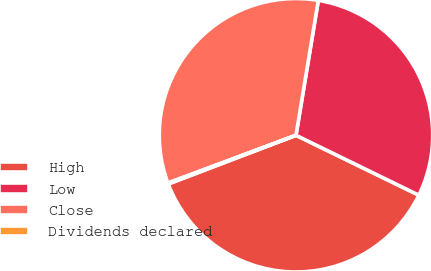<chart> <loc_0><loc_0><loc_500><loc_500><pie_chart><fcel>High<fcel>Low<fcel>Close<fcel>Dividends declared<nl><fcel>36.97%<fcel>29.61%<fcel>33.29%<fcel>0.12%<nl></chart> 